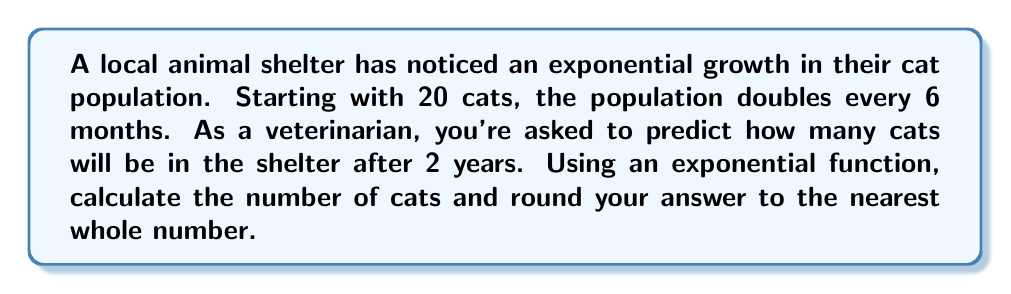Can you answer this question? Let's approach this step-by-step:

1) The basic form of an exponential function is:
   $$ A(t) = A_0 \cdot b^t $$
   where $A_0$ is the initial amount, $b$ is the growth factor, and $t$ is the time.

2) We know:
   - Initial number of cats, $A_0 = 20$
   - The population doubles every 6 months, so $b = 2$
   - We need to find the population after 2 years, which is 4 half-year periods

3) Our function becomes:
   $$ A(t) = 20 \cdot 2^t $$
   where $t$ is measured in half-year intervals

4) After 2 years (4 half-year intervals), we have:
   $$ A(4) = 20 \cdot 2^4 $$

5) Let's calculate:
   $$ A(4) = 20 \cdot 16 = 320 $$

6) Rounding to the nearest whole number isn't necessary here as we already have a whole number.
Answer: 320 cats 